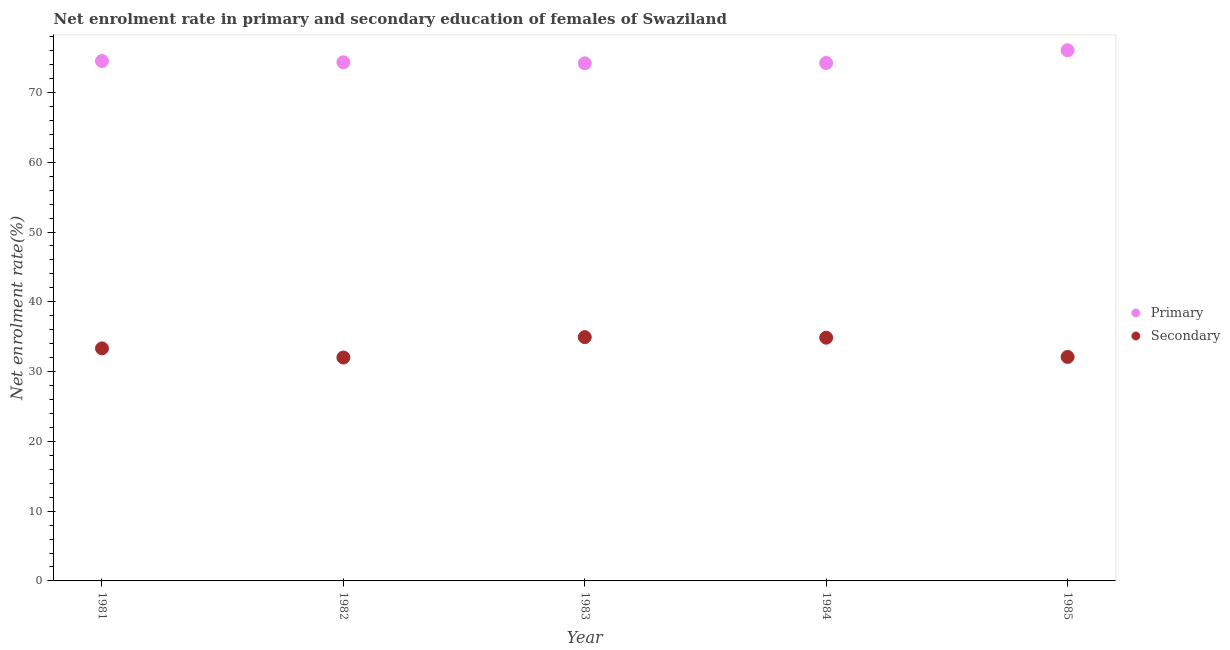What is the enrollment rate in primary education in 1985?
Your answer should be very brief. 76.06. Across all years, what is the maximum enrollment rate in primary education?
Offer a very short reply. 76.06. Across all years, what is the minimum enrollment rate in secondary education?
Offer a very short reply. 32.02. In which year was the enrollment rate in secondary education maximum?
Keep it short and to the point. 1983. In which year was the enrollment rate in primary education minimum?
Keep it short and to the point. 1983. What is the total enrollment rate in primary education in the graph?
Your answer should be very brief. 373.3. What is the difference between the enrollment rate in primary education in 1982 and that in 1984?
Your answer should be compact. 0.1. What is the difference between the enrollment rate in secondary education in 1982 and the enrollment rate in primary education in 1981?
Your answer should be compact. -42.5. What is the average enrollment rate in secondary education per year?
Your response must be concise. 33.45. In the year 1985, what is the difference between the enrollment rate in primary education and enrollment rate in secondary education?
Your response must be concise. 43.96. What is the ratio of the enrollment rate in secondary education in 1981 to that in 1984?
Provide a short and direct response. 0.96. What is the difference between the highest and the second highest enrollment rate in secondary education?
Ensure brevity in your answer.  0.08. What is the difference between the highest and the lowest enrollment rate in secondary education?
Your answer should be very brief. 2.92. In how many years, is the enrollment rate in primary education greater than the average enrollment rate in primary education taken over all years?
Make the answer very short. 1. Is the sum of the enrollment rate in primary education in 1982 and 1983 greater than the maximum enrollment rate in secondary education across all years?
Keep it short and to the point. Yes. Is the enrollment rate in secondary education strictly greater than the enrollment rate in primary education over the years?
Keep it short and to the point. No. Is the enrollment rate in secondary education strictly less than the enrollment rate in primary education over the years?
Make the answer very short. Yes. How many dotlines are there?
Keep it short and to the point. 2. What is the difference between two consecutive major ticks on the Y-axis?
Provide a short and direct response. 10. What is the title of the graph?
Your answer should be very brief. Net enrolment rate in primary and secondary education of females of Swaziland. Does "Netherlands" appear as one of the legend labels in the graph?
Your answer should be compact. No. What is the label or title of the Y-axis?
Provide a succinct answer. Net enrolment rate(%). What is the Net enrolment rate(%) of Primary in 1981?
Your answer should be compact. 74.51. What is the Net enrolment rate(%) of Secondary in 1981?
Offer a very short reply. 33.32. What is the Net enrolment rate(%) in Primary in 1982?
Your answer should be compact. 74.32. What is the Net enrolment rate(%) of Secondary in 1982?
Your answer should be very brief. 32.02. What is the Net enrolment rate(%) of Primary in 1983?
Keep it short and to the point. 74.19. What is the Net enrolment rate(%) of Secondary in 1983?
Offer a very short reply. 34.94. What is the Net enrolment rate(%) in Primary in 1984?
Provide a succinct answer. 74.22. What is the Net enrolment rate(%) of Secondary in 1984?
Provide a succinct answer. 34.86. What is the Net enrolment rate(%) of Primary in 1985?
Ensure brevity in your answer.  76.06. What is the Net enrolment rate(%) in Secondary in 1985?
Your answer should be very brief. 32.1. Across all years, what is the maximum Net enrolment rate(%) of Primary?
Your answer should be compact. 76.06. Across all years, what is the maximum Net enrolment rate(%) in Secondary?
Give a very brief answer. 34.94. Across all years, what is the minimum Net enrolment rate(%) of Primary?
Your answer should be very brief. 74.19. Across all years, what is the minimum Net enrolment rate(%) in Secondary?
Ensure brevity in your answer.  32.02. What is the total Net enrolment rate(%) in Primary in the graph?
Offer a terse response. 373.3. What is the total Net enrolment rate(%) in Secondary in the graph?
Offer a terse response. 167.24. What is the difference between the Net enrolment rate(%) of Primary in 1981 and that in 1982?
Your answer should be compact. 0.19. What is the difference between the Net enrolment rate(%) of Secondary in 1981 and that in 1982?
Make the answer very short. 1.31. What is the difference between the Net enrolment rate(%) in Primary in 1981 and that in 1983?
Offer a terse response. 0.33. What is the difference between the Net enrolment rate(%) in Secondary in 1981 and that in 1983?
Your answer should be very brief. -1.62. What is the difference between the Net enrolment rate(%) of Primary in 1981 and that in 1984?
Ensure brevity in your answer.  0.29. What is the difference between the Net enrolment rate(%) of Secondary in 1981 and that in 1984?
Make the answer very short. -1.53. What is the difference between the Net enrolment rate(%) in Primary in 1981 and that in 1985?
Provide a short and direct response. -1.54. What is the difference between the Net enrolment rate(%) in Secondary in 1981 and that in 1985?
Give a very brief answer. 1.23. What is the difference between the Net enrolment rate(%) of Primary in 1982 and that in 1983?
Your answer should be very brief. 0.14. What is the difference between the Net enrolment rate(%) in Secondary in 1982 and that in 1983?
Ensure brevity in your answer.  -2.92. What is the difference between the Net enrolment rate(%) in Primary in 1982 and that in 1984?
Keep it short and to the point. 0.1. What is the difference between the Net enrolment rate(%) in Secondary in 1982 and that in 1984?
Offer a terse response. -2.84. What is the difference between the Net enrolment rate(%) in Primary in 1982 and that in 1985?
Give a very brief answer. -1.73. What is the difference between the Net enrolment rate(%) of Secondary in 1982 and that in 1985?
Your answer should be compact. -0.08. What is the difference between the Net enrolment rate(%) of Primary in 1983 and that in 1984?
Your answer should be very brief. -0.04. What is the difference between the Net enrolment rate(%) of Secondary in 1983 and that in 1984?
Provide a succinct answer. 0.08. What is the difference between the Net enrolment rate(%) in Primary in 1983 and that in 1985?
Your response must be concise. -1.87. What is the difference between the Net enrolment rate(%) of Secondary in 1983 and that in 1985?
Provide a short and direct response. 2.84. What is the difference between the Net enrolment rate(%) of Primary in 1984 and that in 1985?
Provide a succinct answer. -1.83. What is the difference between the Net enrolment rate(%) in Secondary in 1984 and that in 1985?
Provide a succinct answer. 2.76. What is the difference between the Net enrolment rate(%) of Primary in 1981 and the Net enrolment rate(%) of Secondary in 1982?
Your response must be concise. 42.5. What is the difference between the Net enrolment rate(%) in Primary in 1981 and the Net enrolment rate(%) in Secondary in 1983?
Your answer should be very brief. 39.57. What is the difference between the Net enrolment rate(%) in Primary in 1981 and the Net enrolment rate(%) in Secondary in 1984?
Your answer should be compact. 39.66. What is the difference between the Net enrolment rate(%) in Primary in 1981 and the Net enrolment rate(%) in Secondary in 1985?
Keep it short and to the point. 42.41. What is the difference between the Net enrolment rate(%) in Primary in 1982 and the Net enrolment rate(%) in Secondary in 1983?
Your answer should be very brief. 39.38. What is the difference between the Net enrolment rate(%) of Primary in 1982 and the Net enrolment rate(%) of Secondary in 1984?
Give a very brief answer. 39.47. What is the difference between the Net enrolment rate(%) of Primary in 1982 and the Net enrolment rate(%) of Secondary in 1985?
Offer a very short reply. 42.22. What is the difference between the Net enrolment rate(%) in Primary in 1983 and the Net enrolment rate(%) in Secondary in 1984?
Offer a very short reply. 39.33. What is the difference between the Net enrolment rate(%) in Primary in 1983 and the Net enrolment rate(%) in Secondary in 1985?
Ensure brevity in your answer.  42.09. What is the difference between the Net enrolment rate(%) in Primary in 1984 and the Net enrolment rate(%) in Secondary in 1985?
Offer a terse response. 42.12. What is the average Net enrolment rate(%) in Primary per year?
Provide a succinct answer. 74.66. What is the average Net enrolment rate(%) in Secondary per year?
Make the answer very short. 33.45. In the year 1981, what is the difference between the Net enrolment rate(%) of Primary and Net enrolment rate(%) of Secondary?
Your response must be concise. 41.19. In the year 1982, what is the difference between the Net enrolment rate(%) of Primary and Net enrolment rate(%) of Secondary?
Ensure brevity in your answer.  42.31. In the year 1983, what is the difference between the Net enrolment rate(%) in Primary and Net enrolment rate(%) in Secondary?
Provide a succinct answer. 39.25. In the year 1984, what is the difference between the Net enrolment rate(%) of Primary and Net enrolment rate(%) of Secondary?
Offer a very short reply. 39.37. In the year 1985, what is the difference between the Net enrolment rate(%) of Primary and Net enrolment rate(%) of Secondary?
Ensure brevity in your answer.  43.96. What is the ratio of the Net enrolment rate(%) in Primary in 1981 to that in 1982?
Offer a terse response. 1. What is the ratio of the Net enrolment rate(%) in Secondary in 1981 to that in 1982?
Make the answer very short. 1.04. What is the ratio of the Net enrolment rate(%) in Primary in 1981 to that in 1983?
Your answer should be very brief. 1. What is the ratio of the Net enrolment rate(%) of Secondary in 1981 to that in 1983?
Make the answer very short. 0.95. What is the ratio of the Net enrolment rate(%) in Secondary in 1981 to that in 1984?
Your answer should be compact. 0.96. What is the ratio of the Net enrolment rate(%) of Primary in 1981 to that in 1985?
Provide a short and direct response. 0.98. What is the ratio of the Net enrolment rate(%) in Secondary in 1981 to that in 1985?
Provide a short and direct response. 1.04. What is the ratio of the Net enrolment rate(%) in Secondary in 1982 to that in 1983?
Your response must be concise. 0.92. What is the ratio of the Net enrolment rate(%) in Secondary in 1982 to that in 1984?
Keep it short and to the point. 0.92. What is the ratio of the Net enrolment rate(%) of Primary in 1982 to that in 1985?
Make the answer very short. 0.98. What is the ratio of the Net enrolment rate(%) in Secondary in 1982 to that in 1985?
Provide a succinct answer. 1. What is the ratio of the Net enrolment rate(%) in Primary in 1983 to that in 1985?
Make the answer very short. 0.98. What is the ratio of the Net enrolment rate(%) in Secondary in 1983 to that in 1985?
Keep it short and to the point. 1.09. What is the ratio of the Net enrolment rate(%) of Primary in 1984 to that in 1985?
Ensure brevity in your answer.  0.98. What is the ratio of the Net enrolment rate(%) of Secondary in 1984 to that in 1985?
Provide a short and direct response. 1.09. What is the difference between the highest and the second highest Net enrolment rate(%) of Primary?
Provide a short and direct response. 1.54. What is the difference between the highest and the second highest Net enrolment rate(%) in Secondary?
Ensure brevity in your answer.  0.08. What is the difference between the highest and the lowest Net enrolment rate(%) of Primary?
Keep it short and to the point. 1.87. What is the difference between the highest and the lowest Net enrolment rate(%) in Secondary?
Provide a short and direct response. 2.92. 